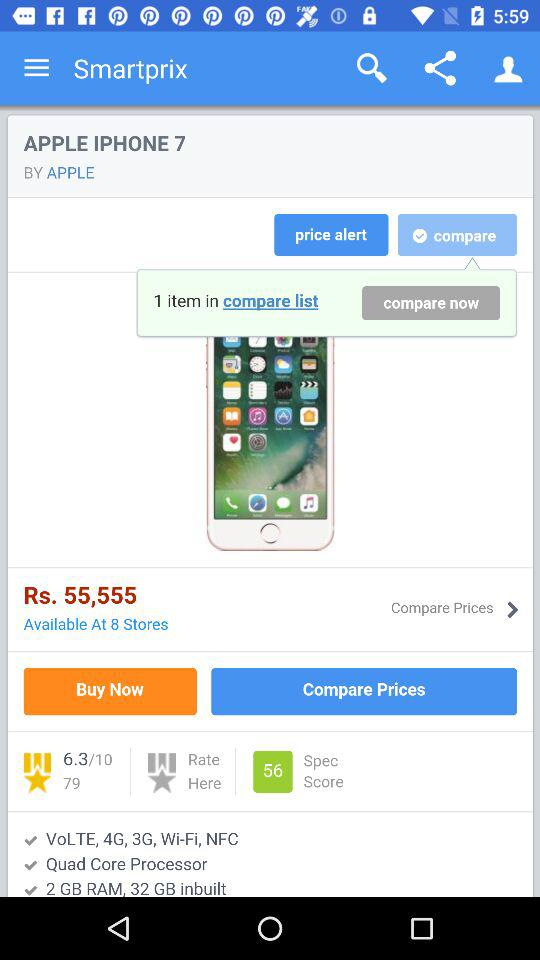What option is selected? The selected option is "compare". 